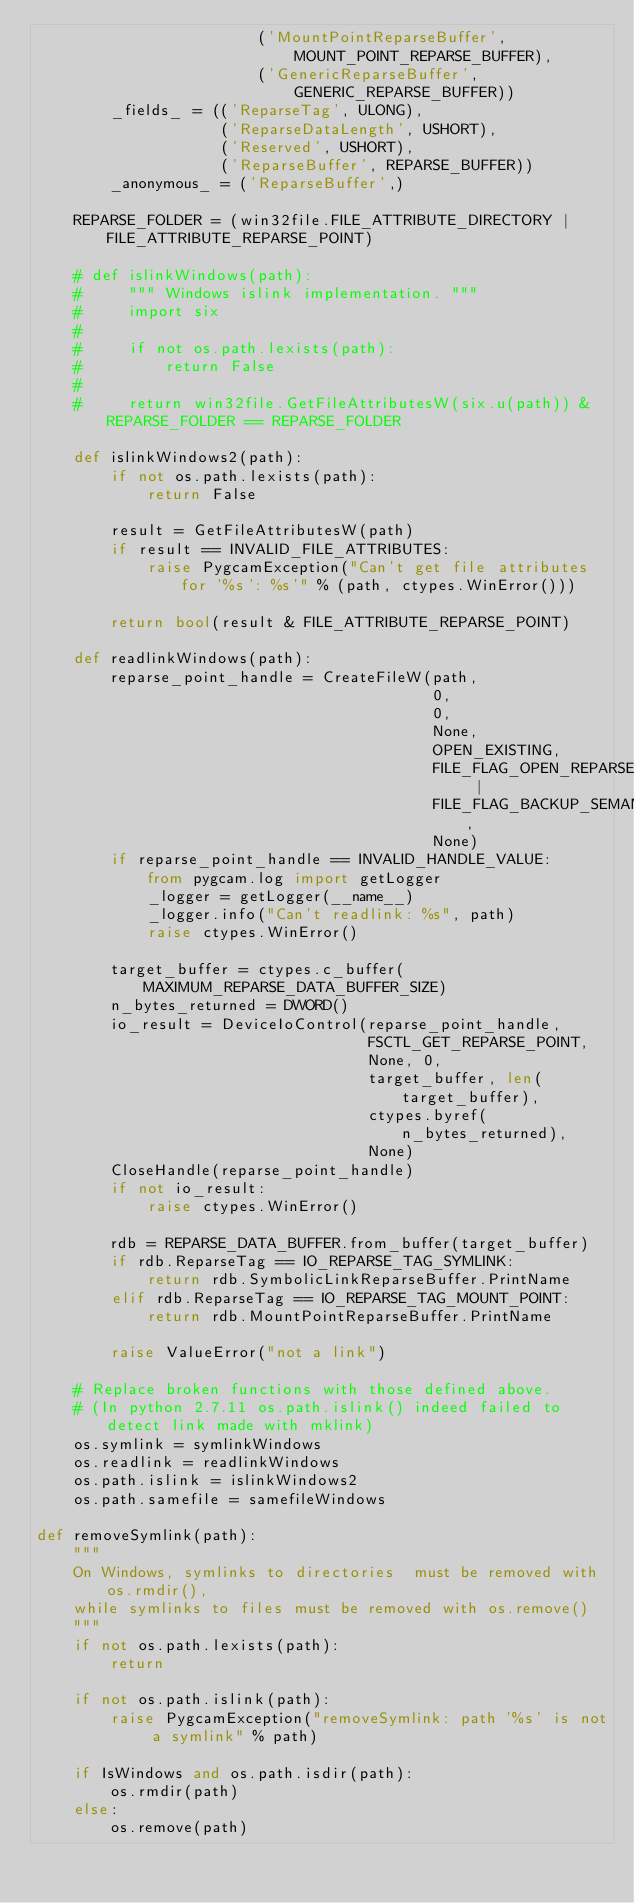<code> <loc_0><loc_0><loc_500><loc_500><_Python_>                        ('MountPointReparseBuffer',
                            MOUNT_POINT_REPARSE_BUFFER),
                        ('GenericReparseBuffer',
                            GENERIC_REPARSE_BUFFER))
        _fields_ = (('ReparseTag', ULONG),
                    ('ReparseDataLength', USHORT),
                    ('Reserved', USHORT),
                    ('ReparseBuffer', REPARSE_BUFFER))
        _anonymous_ = ('ReparseBuffer',)

    REPARSE_FOLDER = (win32file.FILE_ATTRIBUTE_DIRECTORY | FILE_ATTRIBUTE_REPARSE_POINT)

    # def islinkWindows(path):
    #     """ Windows islink implementation. """
    #     import six
    #
    #     if not os.path.lexists(path):
    #         return False
    #
    #     return win32file.GetFileAttributesW(six.u(path)) & REPARSE_FOLDER == REPARSE_FOLDER

    def islinkWindows2(path):
        if not os.path.lexists(path):
            return False

        result = GetFileAttributesW(path)
        if result == INVALID_FILE_ATTRIBUTES:
            raise PygcamException("Can't get file attributes for '%s': %s'" % (path, ctypes.WinError()))

        return bool(result & FILE_ATTRIBUTE_REPARSE_POINT)

    def readlinkWindows(path):
        reparse_point_handle = CreateFileW(path,
                                           0,
                                           0,
                                           None,
                                           OPEN_EXISTING,
                                           FILE_FLAG_OPEN_REPARSE_POINT |
                                           FILE_FLAG_BACKUP_SEMANTICS,
                                           None)
        if reparse_point_handle == INVALID_HANDLE_VALUE:
            from pygcam.log import getLogger
            _logger = getLogger(__name__)
            _logger.info("Can't readlink: %s", path)
            raise ctypes.WinError()

        target_buffer = ctypes.c_buffer(MAXIMUM_REPARSE_DATA_BUFFER_SIZE)
        n_bytes_returned = DWORD()
        io_result = DeviceIoControl(reparse_point_handle,
                                    FSCTL_GET_REPARSE_POINT,
                                    None, 0,
                                    target_buffer, len(target_buffer),
                                    ctypes.byref(n_bytes_returned),
                                    None)
        CloseHandle(reparse_point_handle)
        if not io_result:
            raise ctypes.WinError()

        rdb = REPARSE_DATA_BUFFER.from_buffer(target_buffer)
        if rdb.ReparseTag == IO_REPARSE_TAG_SYMLINK:
            return rdb.SymbolicLinkReparseBuffer.PrintName
        elif rdb.ReparseTag == IO_REPARSE_TAG_MOUNT_POINT:
            return rdb.MountPointReparseBuffer.PrintName

        raise ValueError("not a link")

    # Replace broken functions with those defined above.
    # (In python 2.7.11 os.path.islink() indeed failed to detect link made with mklink)
    os.symlink = symlinkWindows
    os.readlink = readlinkWindows
    os.path.islink = islinkWindows2
    os.path.samefile = samefileWindows

def removeSymlink(path):
    """
    On Windows, symlinks to directories  must be removed with os.rmdir(),
    while symlinks to files must be removed with os.remove()
    """
    if not os.path.lexists(path):
        return

    if not os.path.islink(path):
        raise PygcamException("removeSymlink: path '%s' is not a symlink" % path)

    if IsWindows and os.path.isdir(path):
        os.rmdir(path)
    else:
        os.remove(path)

</code> 